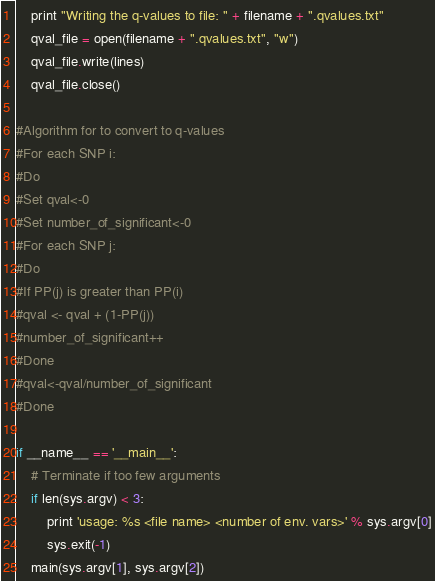<code> <loc_0><loc_0><loc_500><loc_500><_Python_>    print "Writing the q-values to file: " + filename + ".qvalues.txt"
    qval_file = open(filename + ".qvalues.txt", "w")
    qval_file.write(lines)
    qval_file.close()

#Algorithm for to convert to q-values
#For each SNP i:
#Do
#Set qval<-0
#Set number_of_significant<-0
#For each SNP j:
#Do
#If PP(j) is greater than PP(i)
#qval <- qval + (1-PP(j))
#number_of_significant++
#Done
#qval<-qval/number_of_significant
#Done

if __name__ == '__main__':
    # Terminate if too few arguments
    if len(sys.argv) < 3:
        print 'usage: %s <file name> <number of env. vars>' % sys.argv[0]
        sys.exit(-1)
    main(sys.argv[1], sys.argv[2])

</code> 